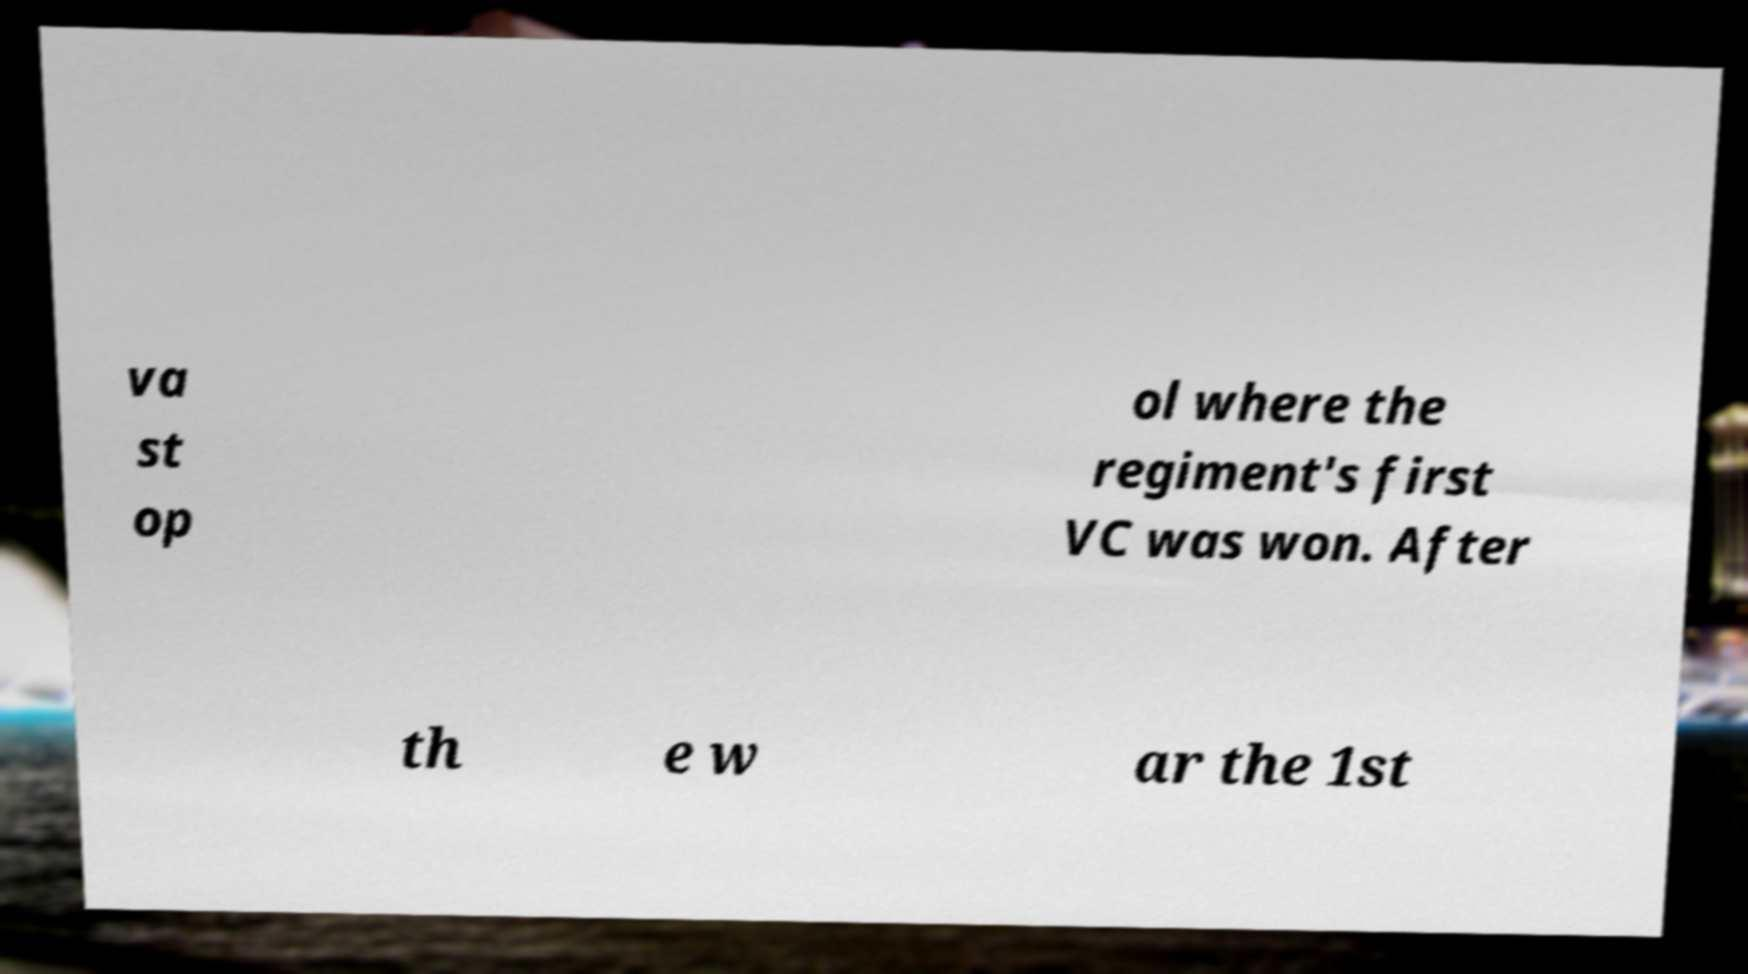Can you accurately transcribe the text from the provided image for me? va st op ol where the regiment's first VC was won. After th e w ar the 1st 